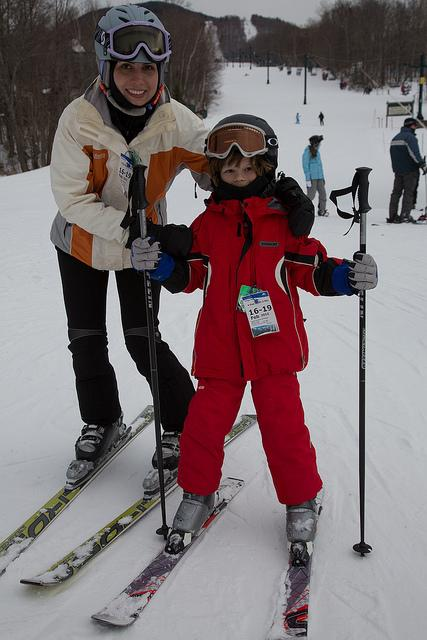What kind of tag hangs from the child in red's jacket?

Choices:
A) ski pass
B) birth certificate
C) hall pass
D) bank statement birth certificate 